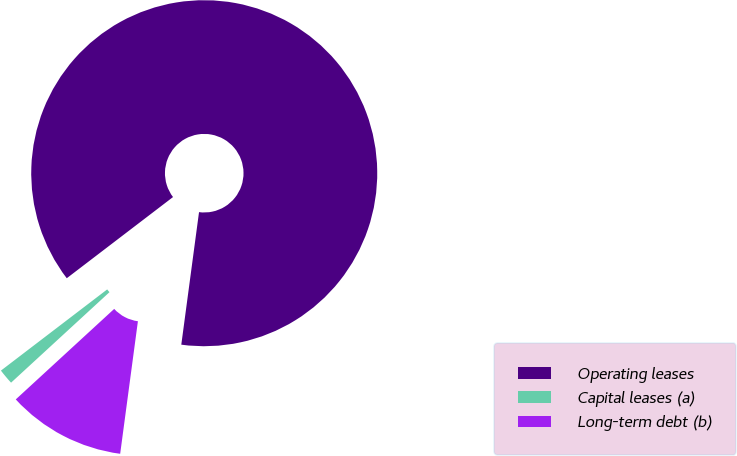Convert chart to OTSL. <chart><loc_0><loc_0><loc_500><loc_500><pie_chart><fcel>Operating leases<fcel>Capital leases (a)<fcel>Long-term debt (b)<nl><fcel>87.5%<fcel>1.45%<fcel>11.05%<nl></chart> 